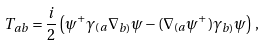<formula> <loc_0><loc_0><loc_500><loc_500>T _ { a b } = \frac { i } { 2 } \left ( \psi ^ { + } \gamma _ { ( a } \nabla _ { b ) } \psi - ( \nabla _ { ( a } \psi ^ { + } ) \gamma _ { b ) } \psi \right ) \, ,</formula> 